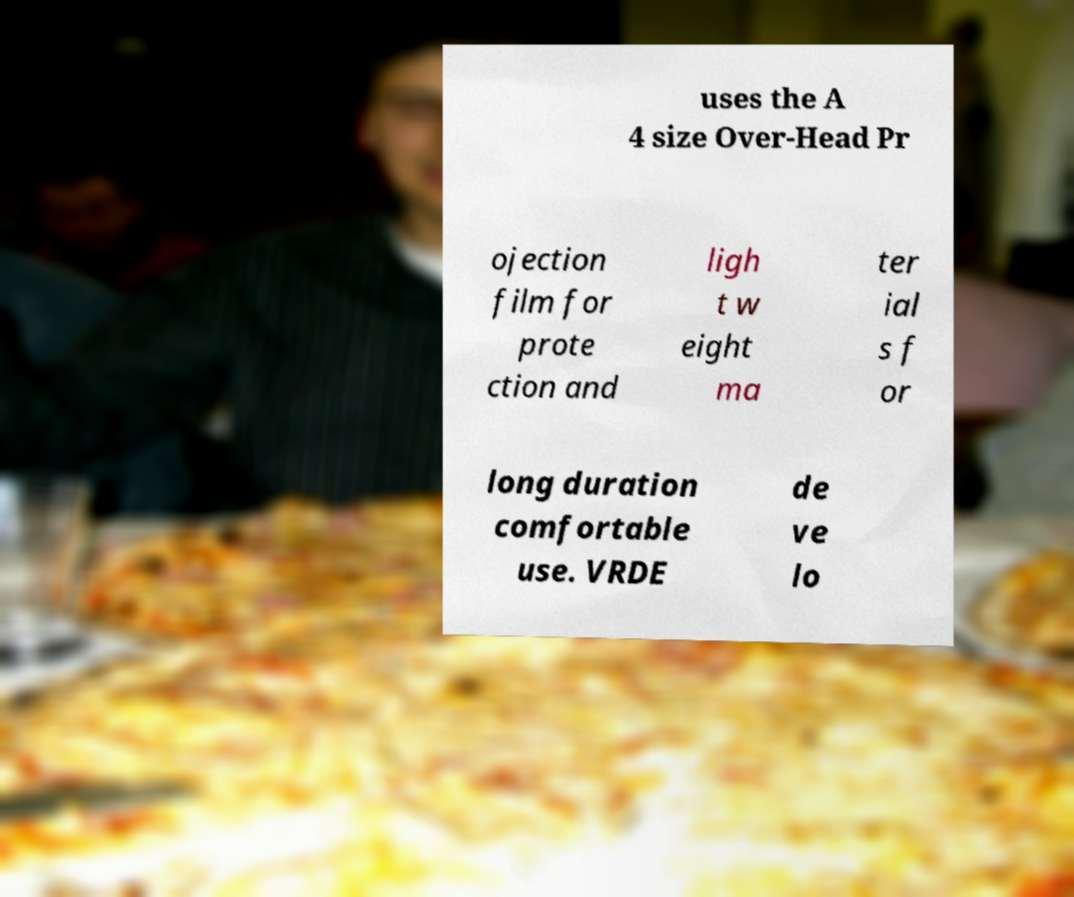I need the written content from this picture converted into text. Can you do that? uses the A 4 size Over-Head Pr ojection film for prote ction and ligh t w eight ma ter ial s f or long duration comfortable use. VRDE de ve lo 